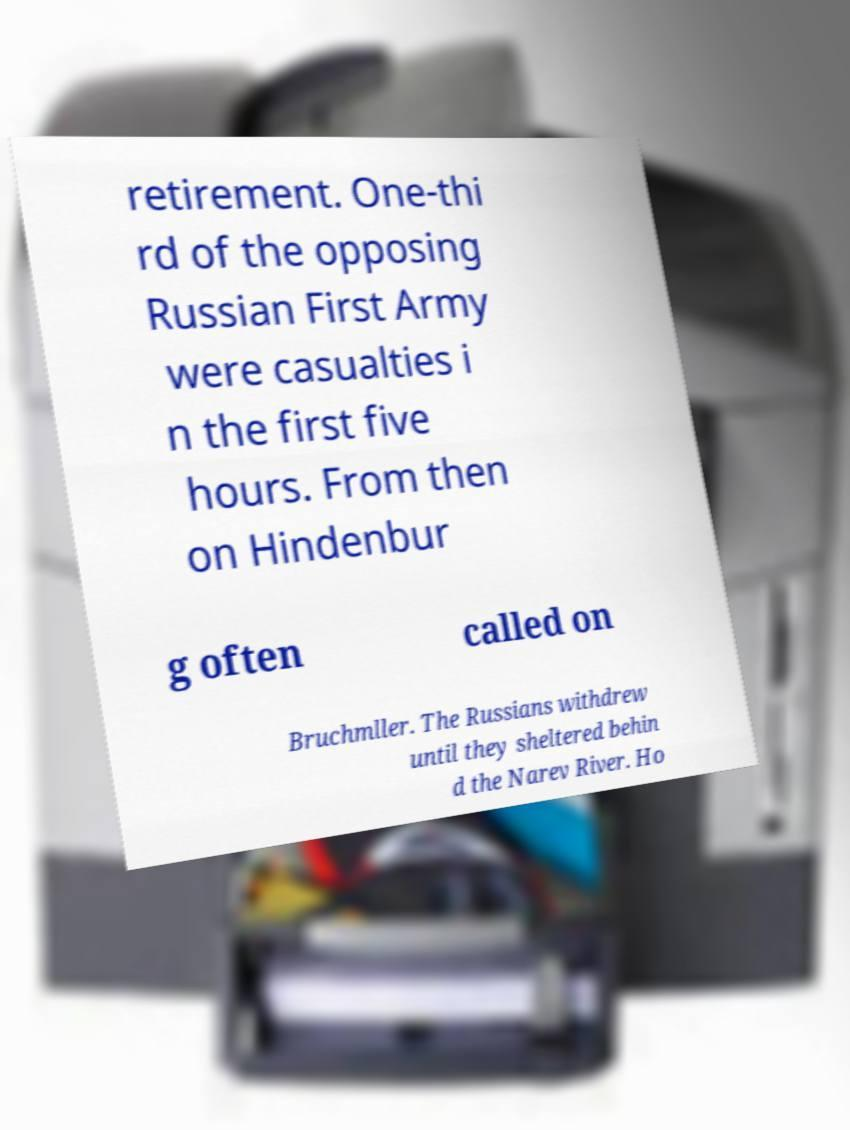Could you extract and type out the text from this image? retirement. One-thi rd of the opposing Russian First Army were casualties i n the first five hours. From then on Hindenbur g often called on Bruchmller. The Russians withdrew until they sheltered behin d the Narev River. Ho 